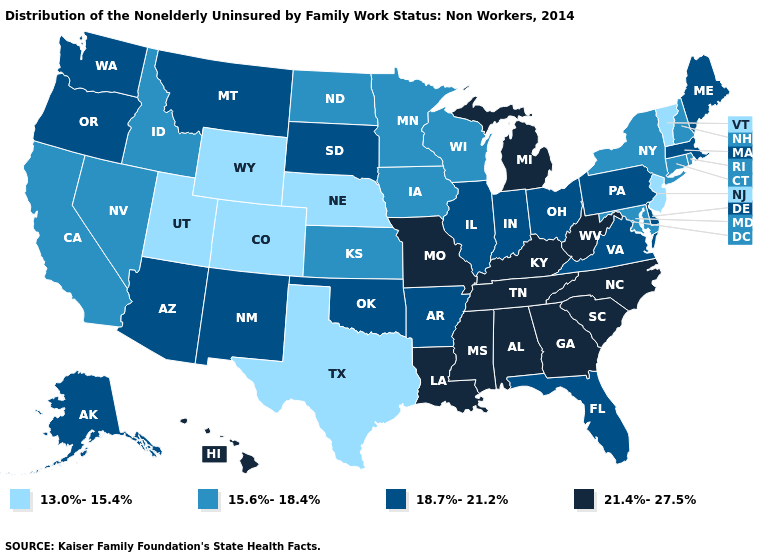Name the states that have a value in the range 18.7%-21.2%?
Concise answer only. Alaska, Arizona, Arkansas, Delaware, Florida, Illinois, Indiana, Maine, Massachusetts, Montana, New Mexico, Ohio, Oklahoma, Oregon, Pennsylvania, South Dakota, Virginia, Washington. What is the value of Alabama?
Give a very brief answer. 21.4%-27.5%. Does the first symbol in the legend represent the smallest category?
Concise answer only. Yes. Does South Carolina have the same value as Kentucky?
Answer briefly. Yes. What is the value of South Carolina?
Short answer required. 21.4%-27.5%. What is the highest value in the USA?
Give a very brief answer. 21.4%-27.5%. What is the value of Idaho?
Answer briefly. 15.6%-18.4%. Does Idaho have the highest value in the USA?
Concise answer only. No. Name the states that have a value in the range 18.7%-21.2%?
Give a very brief answer. Alaska, Arizona, Arkansas, Delaware, Florida, Illinois, Indiana, Maine, Massachusetts, Montana, New Mexico, Ohio, Oklahoma, Oregon, Pennsylvania, South Dakota, Virginia, Washington. Name the states that have a value in the range 15.6%-18.4%?
Concise answer only. California, Connecticut, Idaho, Iowa, Kansas, Maryland, Minnesota, Nevada, New Hampshire, New York, North Dakota, Rhode Island, Wisconsin. What is the highest value in the MidWest ?
Concise answer only. 21.4%-27.5%. Among the states that border Texas , does Oklahoma have the lowest value?
Keep it brief. Yes. Among the states that border Kentucky , which have the highest value?
Give a very brief answer. Missouri, Tennessee, West Virginia. Which states have the highest value in the USA?
Give a very brief answer. Alabama, Georgia, Hawaii, Kentucky, Louisiana, Michigan, Mississippi, Missouri, North Carolina, South Carolina, Tennessee, West Virginia. 